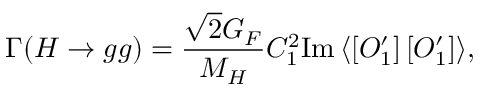Convert formula to latex. <formula><loc_0><loc_0><loc_500><loc_500>\Gamma ( H \to g g ) = \frac { \sqrt { 2 } G _ { F } } { M _ { H } } C _ { 1 } ^ { 2 } I m \, \langle \left [ O _ { 1 } ^ { \prime } \right ] \left [ O _ { 1 } ^ { \prime } \right ] \rangle ,</formula> 